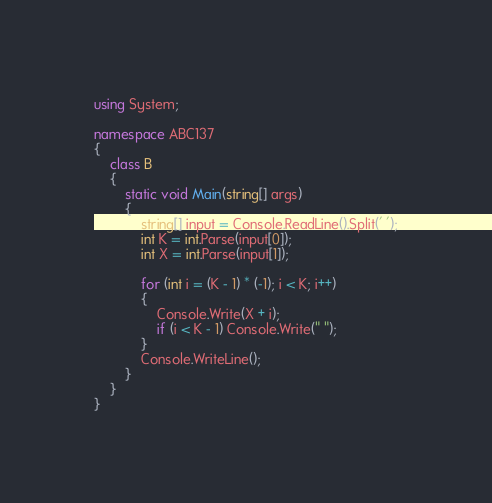Convert code to text. <code><loc_0><loc_0><loc_500><loc_500><_C#_>using System;

namespace ABC137
{
    class B
    {
        static void Main(string[] args)
        {
            string[] input = Console.ReadLine().Split(' ');
            int K = int.Parse(input[0]);
            int X = int.Parse(input[1]);

            for (int i = (K - 1) * (-1); i < K; i++)
            {
                Console.Write(X + i);
                if (i < K - 1) Console.Write(" ");
            }
            Console.WriteLine();
        }
    }
}
</code> 